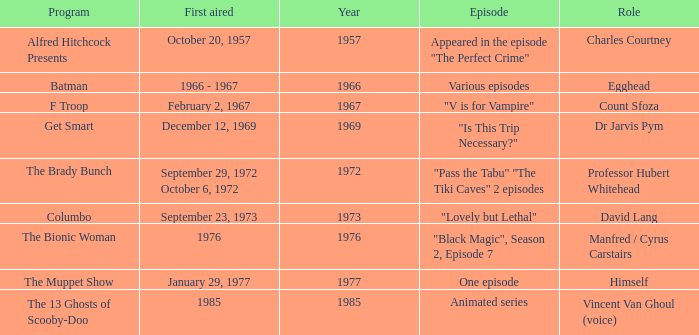What's the first aired date of the Animated Series episode? 1985.0. 